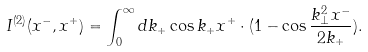Convert formula to latex. <formula><loc_0><loc_0><loc_500><loc_500>I ^ { ( 2 ) } ( x ^ { - } , x ^ { + } ) = \int _ { 0 } ^ { \infty } d k _ { + } \cos k _ { + } x ^ { + } \cdot ( 1 - \cos \frac { k _ { \bot } ^ { 2 } x ^ { - } } { 2 k _ { + } } ) .</formula> 